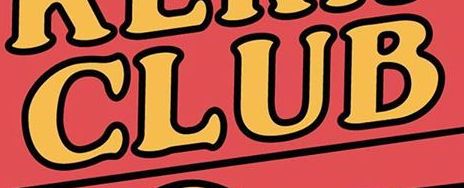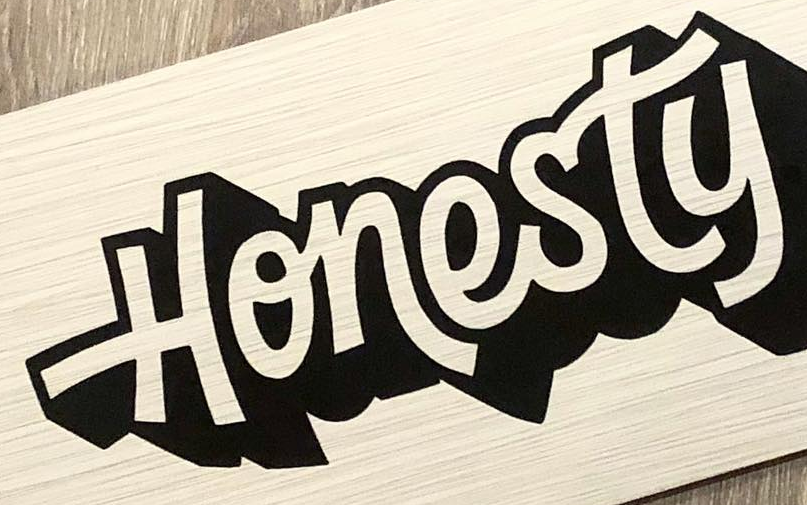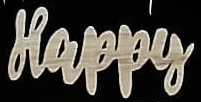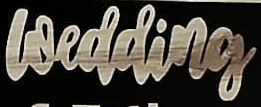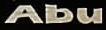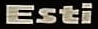What text is displayed in these images sequentially, separated by a semicolon? CLUB; Honesty; Happy; wedding; Abu; Esti 